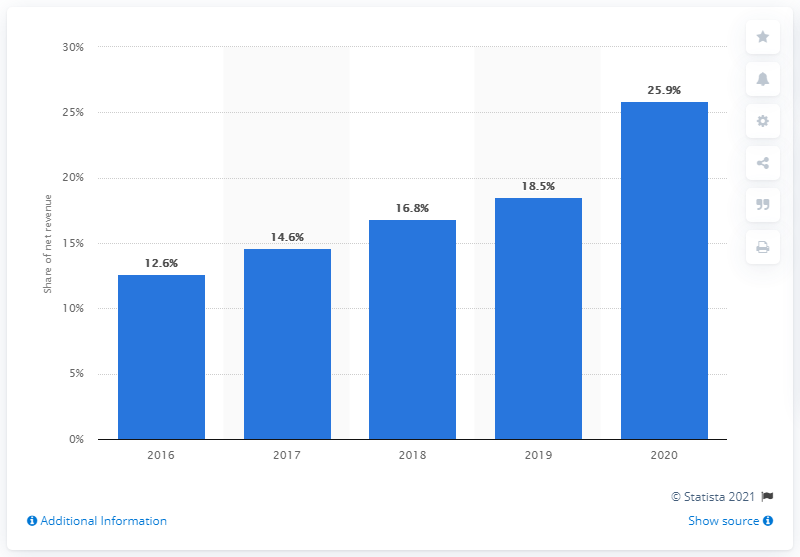Indicate a few pertinent items in this graphic. In 2020, Crocs generated 25.9% of its global net revenue through the e-commerce channel. 